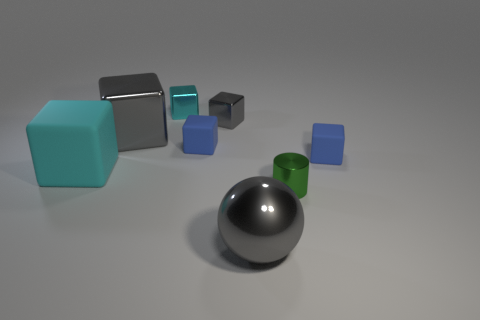Subtract all big matte blocks. How many blocks are left? 5 Subtract all cyan blocks. How many blocks are left? 4 Subtract 3 cubes. How many cubes are left? 3 Subtract all purple blocks. Subtract all brown spheres. How many blocks are left? 6 Add 1 tiny purple rubber objects. How many objects exist? 9 Subtract all balls. How many objects are left? 7 Subtract all small cyan metal objects. Subtract all red rubber cylinders. How many objects are left? 7 Add 7 gray metallic balls. How many gray metallic balls are left? 8 Add 2 small cyan things. How many small cyan things exist? 3 Subtract 0 purple cylinders. How many objects are left? 8 